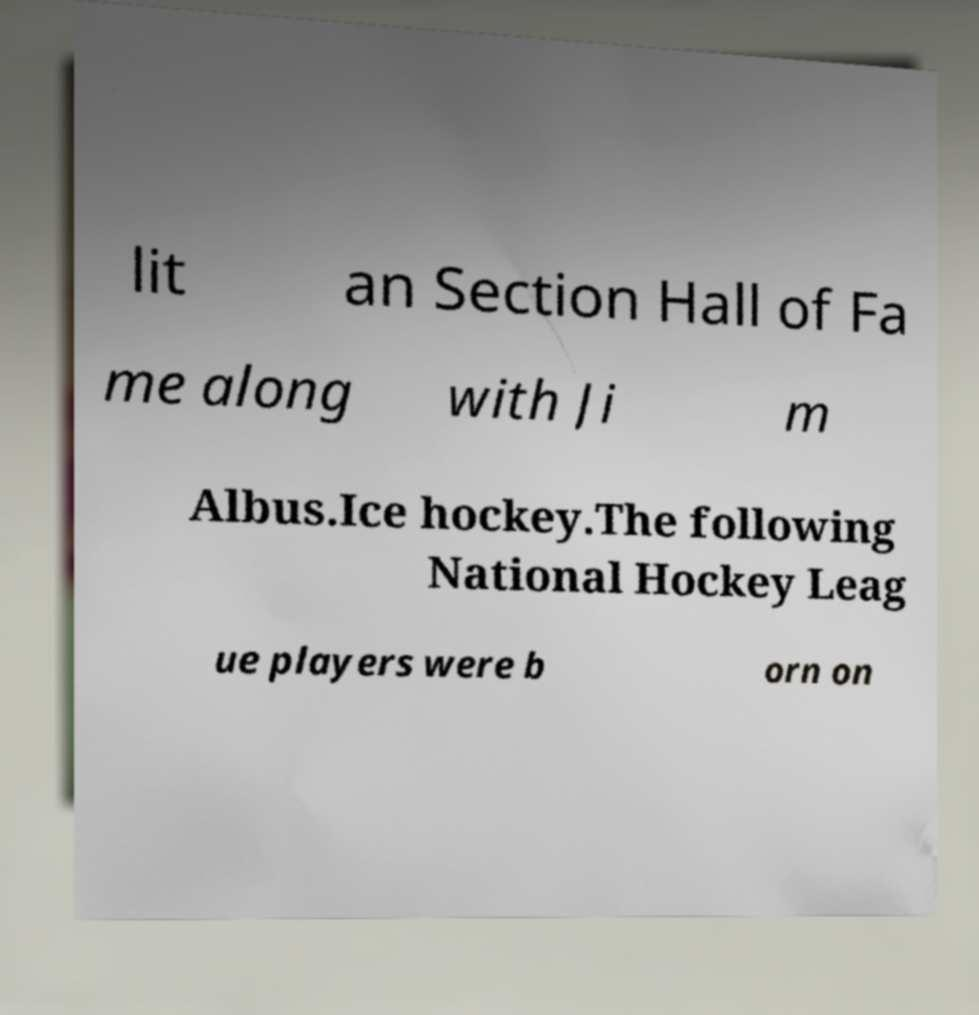Please identify and transcribe the text found in this image. lit an Section Hall of Fa me along with Ji m Albus.Ice hockey.The following National Hockey Leag ue players were b orn on 